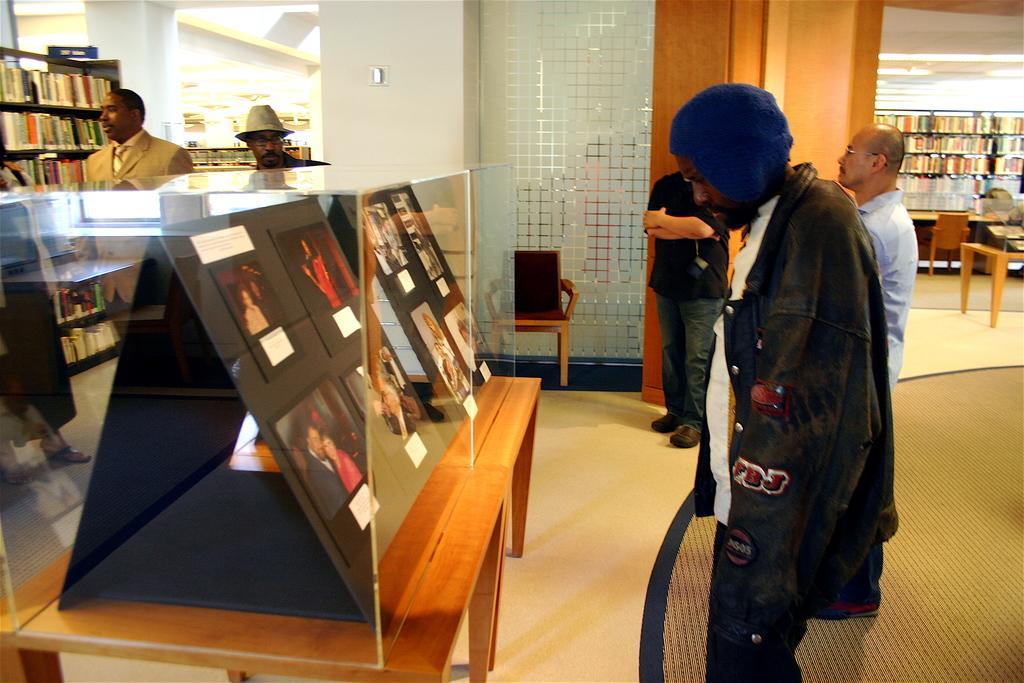Can you describe this image briefly? there are tables on which glass boxes are kept. there are people at the right , standing and watching that. behind that there are chairs and shelves. at the left there are people standing. 